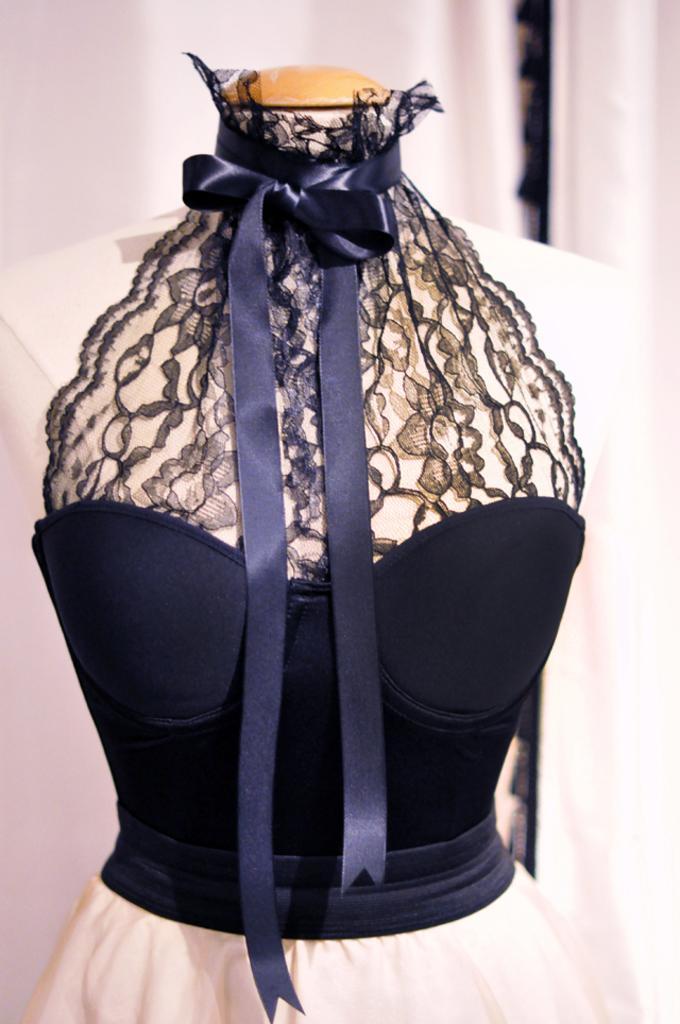Can you describe this image briefly? In this image I can see colorful dress attached to the hanger. 